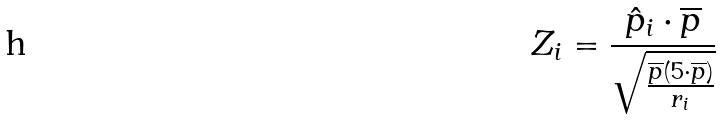<formula> <loc_0><loc_0><loc_500><loc_500>Z _ { i } = \frac { \hat { p } _ { i } \cdot \overline { p } } { \sqrt { \frac { \overline { p } ( 5 \cdot \overline { p } ) } { r _ { i } } } }</formula> 